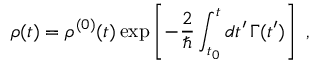Convert formula to latex. <formula><loc_0><loc_0><loc_500><loc_500>\rho ( t ) = \rho ^ { ( 0 ) } ( t ) \exp \left [ - \frac { 2 } { } \int _ { t _ { 0 } } ^ { t } d t ^ { \prime } \, \Gamma ( t ^ { \prime } ) \right ] \, ,</formula> 